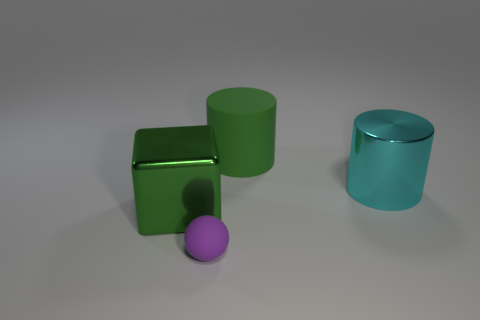Do the block and the big rubber cylinder have the same color?
Keep it short and to the point. Yes. Is there anything else that has the same shape as the large green metallic thing?
Make the answer very short. No. Is there any other thing that has the same size as the sphere?
Your answer should be very brief. No. How many spheres are tiny things or big green metallic things?
Give a very brief answer. 1. What number of objects are spheres or small things that are in front of the cyan metallic thing?
Give a very brief answer. 1. Is there a cyan object?
Your answer should be very brief. Yes. What number of rubber cylinders have the same color as the big matte object?
Your response must be concise. 0. What material is the thing that is the same color as the big matte cylinder?
Your response must be concise. Metal. What size is the cylinder on the right side of the green thing on the right side of the matte ball?
Make the answer very short. Large. Are there any cyan cubes made of the same material as the purple sphere?
Make the answer very short. No. 